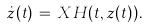Convert formula to latex. <formula><loc_0><loc_0><loc_500><loc_500>\dot { z } ( t ) \, = \, X H ( t , z ( t ) ) .</formula> 